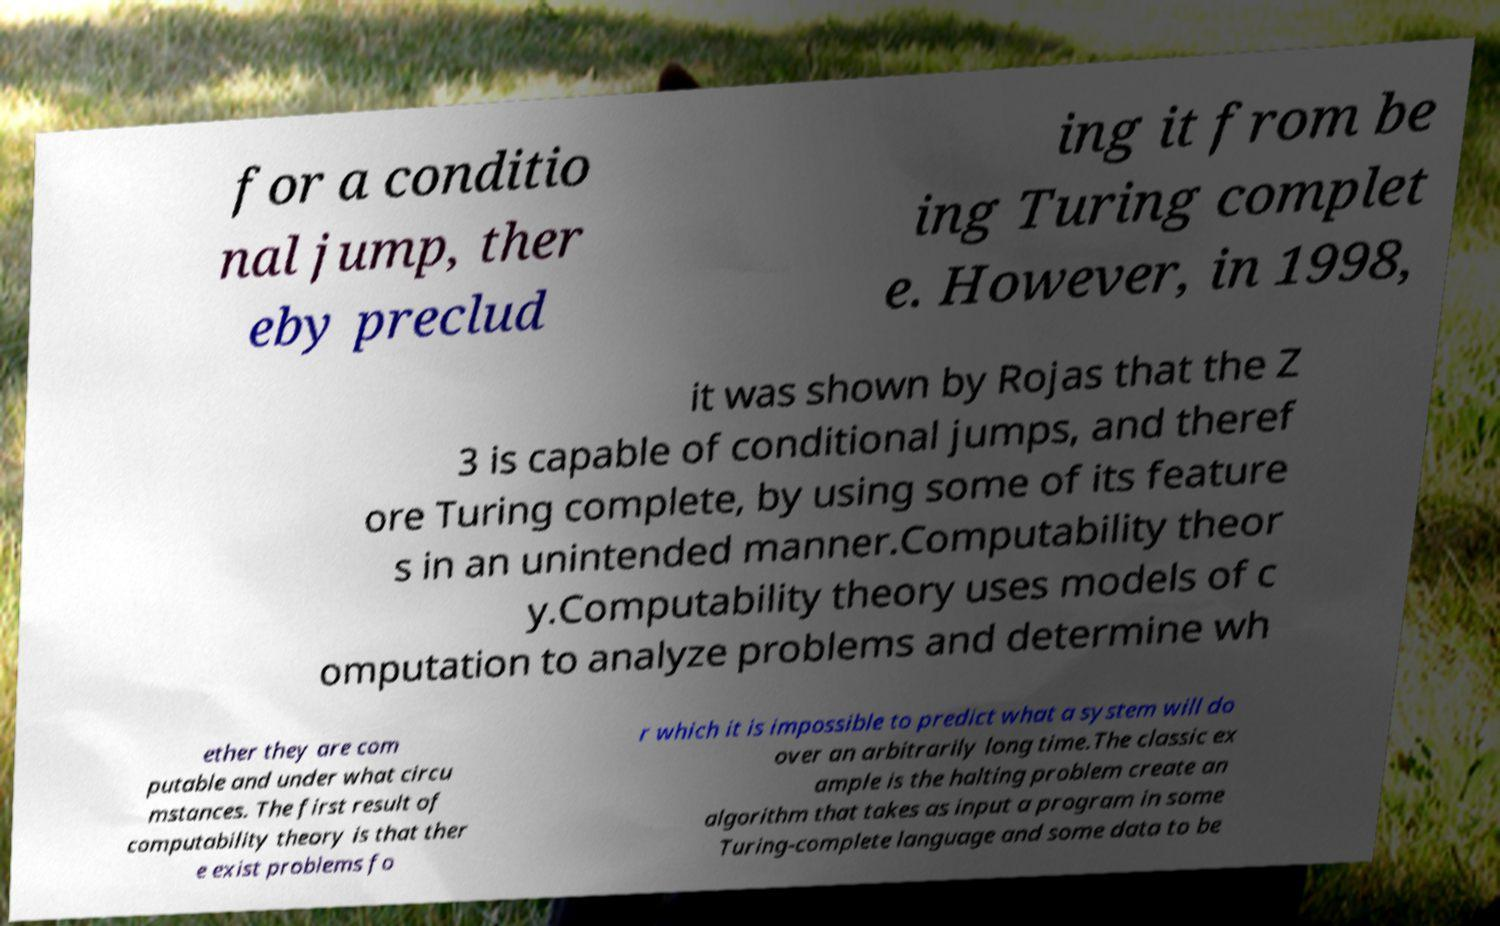Can you read and provide the text displayed in the image?This photo seems to have some interesting text. Can you extract and type it out for me? for a conditio nal jump, ther eby preclud ing it from be ing Turing complet e. However, in 1998, it was shown by Rojas that the Z 3 is capable of conditional jumps, and theref ore Turing complete, by using some of its feature s in an unintended manner.Computability theor y.Computability theory uses models of c omputation to analyze problems and determine wh ether they are com putable and under what circu mstances. The first result of computability theory is that ther e exist problems fo r which it is impossible to predict what a system will do over an arbitrarily long time.The classic ex ample is the halting problem create an algorithm that takes as input a program in some Turing-complete language and some data to be 